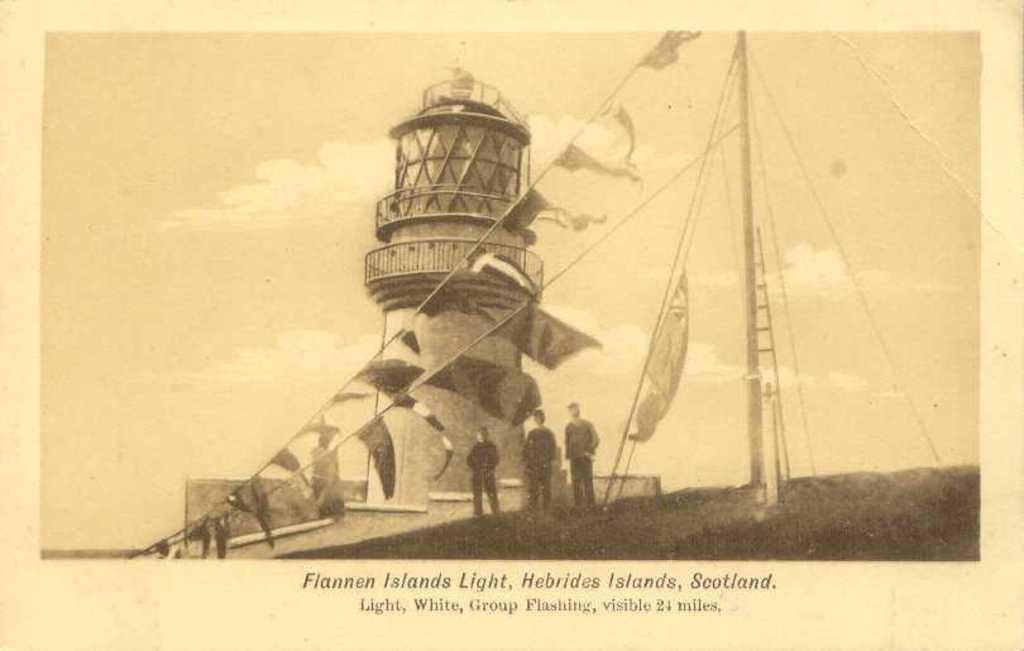What is the main structure visible in the image? There is a tower in the image. What type of decorations are present in the image? There are paper flags in the image. What type of material is used for the decorations? The paper flags are made of paper. What else can be seen in the image besides the tower and flags? There are ropes, objects, people, and text written at the bottom portion of the image. What type of medical advice is the doctor giving in the image? There is no doctor present in the image, so no medical advice can be given. What type of office furniture can be seen in the image? There is no office furniture present in the image. 